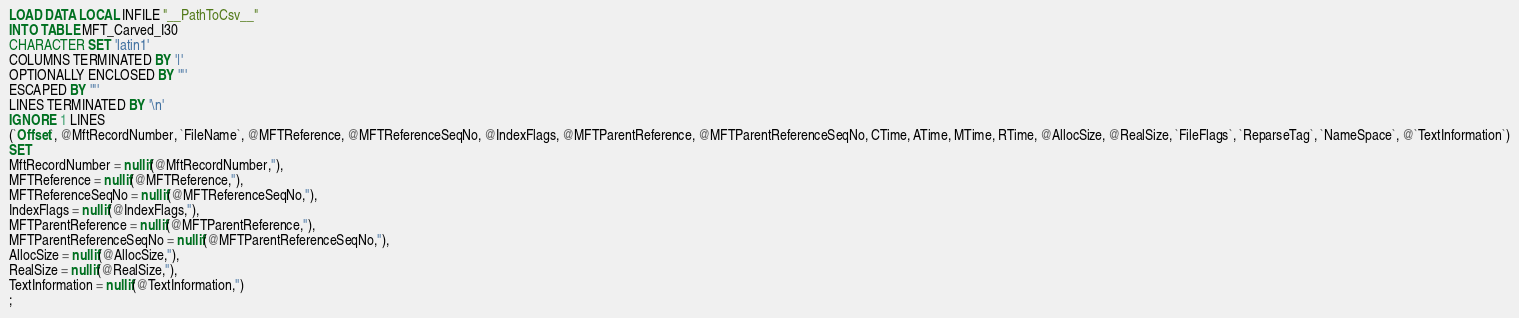Convert code to text. <code><loc_0><loc_0><loc_500><loc_500><_SQL_>LOAD DATA LOCAL INFILE "__PathToCsv__"
INTO TABLE MFT_Carved_I30
CHARACTER SET 'latin1'
COLUMNS TERMINATED BY '|'
OPTIONALLY ENCLOSED BY '"'
ESCAPED BY '"'
LINES TERMINATED BY '\n'
IGNORE 1 LINES
(`Offset`, @MftRecordNumber, `FileName`, @MFTReference, @MFTReferenceSeqNo, @IndexFlags, @MFTParentReference, @MFTParentReferenceSeqNo, CTime, ATime, MTime, RTime, @AllocSize, @RealSize, `FileFlags`, `ReparseTag`, `NameSpace`, @`TextInformation`)
SET 
MftRecordNumber = nullif(@MftRecordNumber,''),
MFTReference = nullif(@MFTReference,''),
MFTReferenceSeqNo = nullif(@MFTReferenceSeqNo,''),
IndexFlags = nullif(@IndexFlags,''),
MFTParentReference = nullif(@MFTParentReference,''),
MFTParentReferenceSeqNo = nullif(@MFTParentReferenceSeqNo,''),
AllocSize = nullif(@AllocSize,''),
RealSize = nullif(@RealSize,''),
TextInformation = nullif(@TextInformation,'')
;</code> 